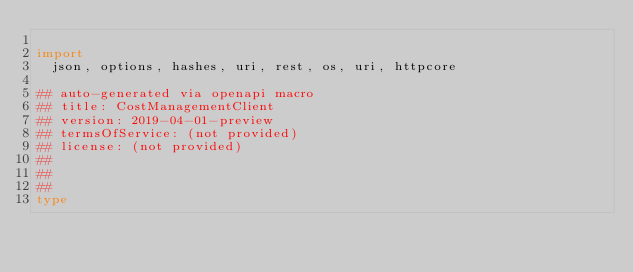<code> <loc_0><loc_0><loc_500><loc_500><_Nim_>
import
  json, options, hashes, uri, rest, os, uri, httpcore

## auto-generated via openapi macro
## title: CostManagementClient
## version: 2019-04-01-preview
## termsOfService: (not provided)
## license: (not provided)
## 
## 
## 
type</code> 